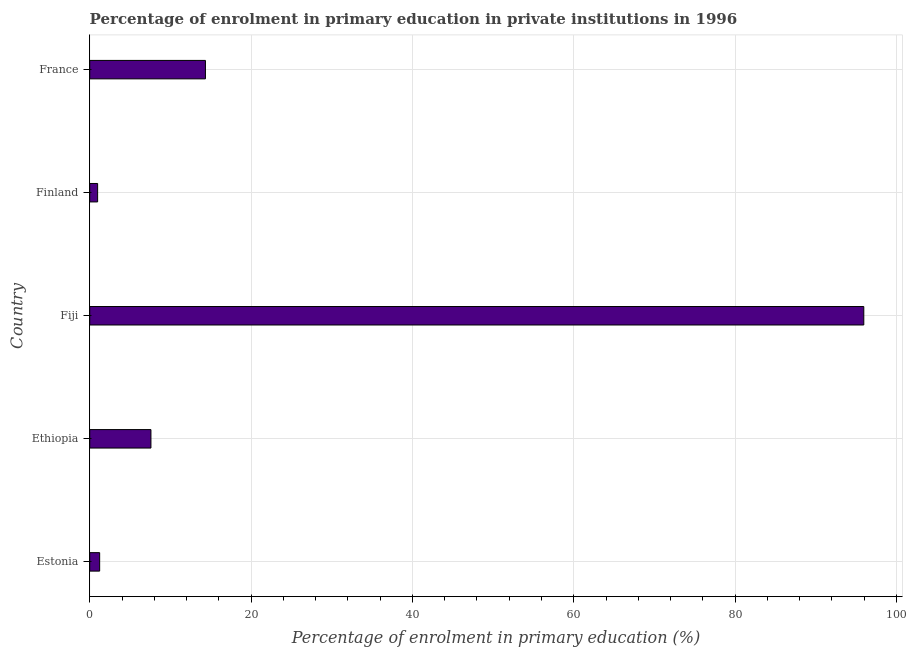Does the graph contain grids?
Ensure brevity in your answer.  Yes. What is the title of the graph?
Provide a short and direct response. Percentage of enrolment in primary education in private institutions in 1996. What is the label or title of the X-axis?
Make the answer very short. Percentage of enrolment in primary education (%). What is the enrolment percentage in primary education in Ethiopia?
Your answer should be very brief. 7.59. Across all countries, what is the maximum enrolment percentage in primary education?
Make the answer very short. 95.95. Across all countries, what is the minimum enrolment percentage in primary education?
Offer a very short reply. 0.98. In which country was the enrolment percentage in primary education maximum?
Provide a succinct answer. Fiji. In which country was the enrolment percentage in primary education minimum?
Give a very brief answer. Finland. What is the sum of the enrolment percentage in primary education?
Offer a terse response. 120.09. What is the difference between the enrolment percentage in primary education in Ethiopia and Fiji?
Give a very brief answer. -88.37. What is the average enrolment percentage in primary education per country?
Your answer should be compact. 24.02. What is the median enrolment percentage in primary education?
Keep it short and to the point. 7.59. What is the ratio of the enrolment percentage in primary education in Ethiopia to that in Finland?
Make the answer very short. 7.76. Is the enrolment percentage in primary education in Fiji less than that in France?
Your answer should be compact. No. What is the difference between the highest and the second highest enrolment percentage in primary education?
Offer a very short reply. 81.61. What is the difference between the highest and the lowest enrolment percentage in primary education?
Give a very brief answer. 94.98. In how many countries, is the enrolment percentage in primary education greater than the average enrolment percentage in primary education taken over all countries?
Provide a succinct answer. 1. How many bars are there?
Your answer should be compact. 5. How many countries are there in the graph?
Your answer should be very brief. 5. What is the difference between two consecutive major ticks on the X-axis?
Offer a very short reply. 20. Are the values on the major ticks of X-axis written in scientific E-notation?
Offer a terse response. No. What is the Percentage of enrolment in primary education (%) in Estonia?
Ensure brevity in your answer.  1.23. What is the Percentage of enrolment in primary education (%) of Ethiopia?
Keep it short and to the point. 7.59. What is the Percentage of enrolment in primary education (%) of Fiji?
Offer a terse response. 95.95. What is the Percentage of enrolment in primary education (%) of Finland?
Offer a very short reply. 0.98. What is the Percentage of enrolment in primary education (%) in France?
Keep it short and to the point. 14.34. What is the difference between the Percentage of enrolment in primary education (%) in Estonia and Ethiopia?
Offer a very short reply. -6.36. What is the difference between the Percentage of enrolment in primary education (%) in Estonia and Fiji?
Offer a terse response. -94.72. What is the difference between the Percentage of enrolment in primary education (%) in Estonia and Finland?
Give a very brief answer. 0.25. What is the difference between the Percentage of enrolment in primary education (%) in Estonia and France?
Offer a very short reply. -13.11. What is the difference between the Percentage of enrolment in primary education (%) in Ethiopia and Fiji?
Make the answer very short. -88.37. What is the difference between the Percentage of enrolment in primary education (%) in Ethiopia and Finland?
Your answer should be very brief. 6.61. What is the difference between the Percentage of enrolment in primary education (%) in Ethiopia and France?
Provide a succinct answer. -6.76. What is the difference between the Percentage of enrolment in primary education (%) in Fiji and Finland?
Your answer should be very brief. 94.98. What is the difference between the Percentage of enrolment in primary education (%) in Fiji and France?
Offer a terse response. 81.61. What is the difference between the Percentage of enrolment in primary education (%) in Finland and France?
Your response must be concise. -13.37. What is the ratio of the Percentage of enrolment in primary education (%) in Estonia to that in Ethiopia?
Your answer should be compact. 0.16. What is the ratio of the Percentage of enrolment in primary education (%) in Estonia to that in Fiji?
Keep it short and to the point. 0.01. What is the ratio of the Percentage of enrolment in primary education (%) in Estonia to that in Finland?
Provide a short and direct response. 1.26. What is the ratio of the Percentage of enrolment in primary education (%) in Estonia to that in France?
Offer a terse response. 0.09. What is the ratio of the Percentage of enrolment in primary education (%) in Ethiopia to that in Fiji?
Make the answer very short. 0.08. What is the ratio of the Percentage of enrolment in primary education (%) in Ethiopia to that in Finland?
Your answer should be very brief. 7.76. What is the ratio of the Percentage of enrolment in primary education (%) in Ethiopia to that in France?
Give a very brief answer. 0.53. What is the ratio of the Percentage of enrolment in primary education (%) in Fiji to that in Finland?
Ensure brevity in your answer.  98.14. What is the ratio of the Percentage of enrolment in primary education (%) in Fiji to that in France?
Give a very brief answer. 6.69. What is the ratio of the Percentage of enrolment in primary education (%) in Finland to that in France?
Your answer should be compact. 0.07. 